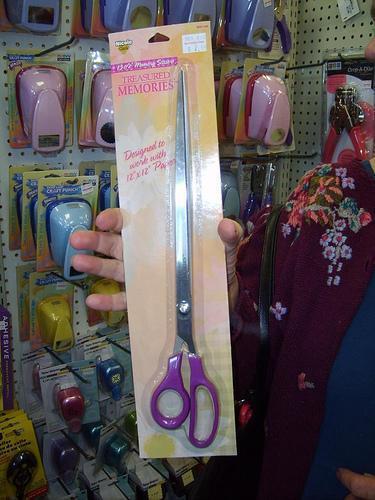How many scissors are in the photo?
Give a very brief answer. 1. How many adult cows are in the picture?
Give a very brief answer. 0. 